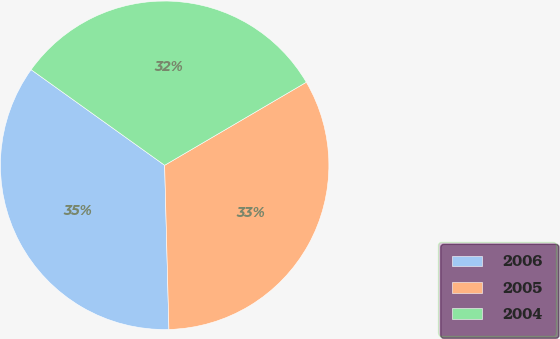Convert chart to OTSL. <chart><loc_0><loc_0><loc_500><loc_500><pie_chart><fcel>2006<fcel>2005<fcel>2004<nl><fcel>35.3%<fcel>33.02%<fcel>31.67%<nl></chart> 